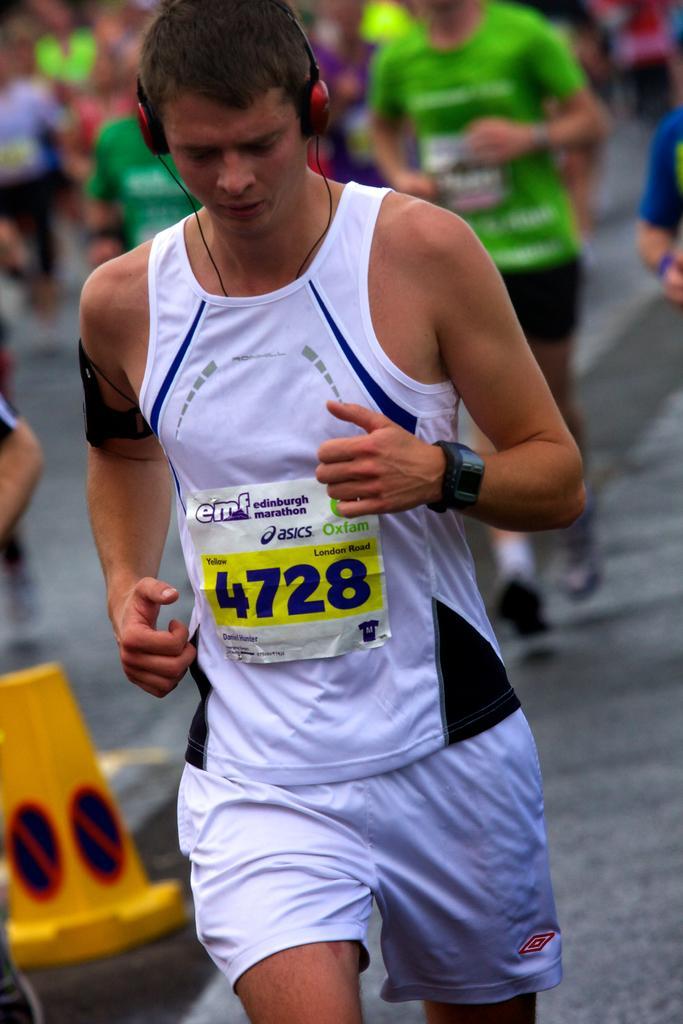In one or two sentences, can you explain what this image depicts? This is the man running. He wore a T-shirt, headset, short and wrist watch. This looks like a badge. In the background, I can see few people running. On the left side of the image, that looks like an object, which is yellow in color. 